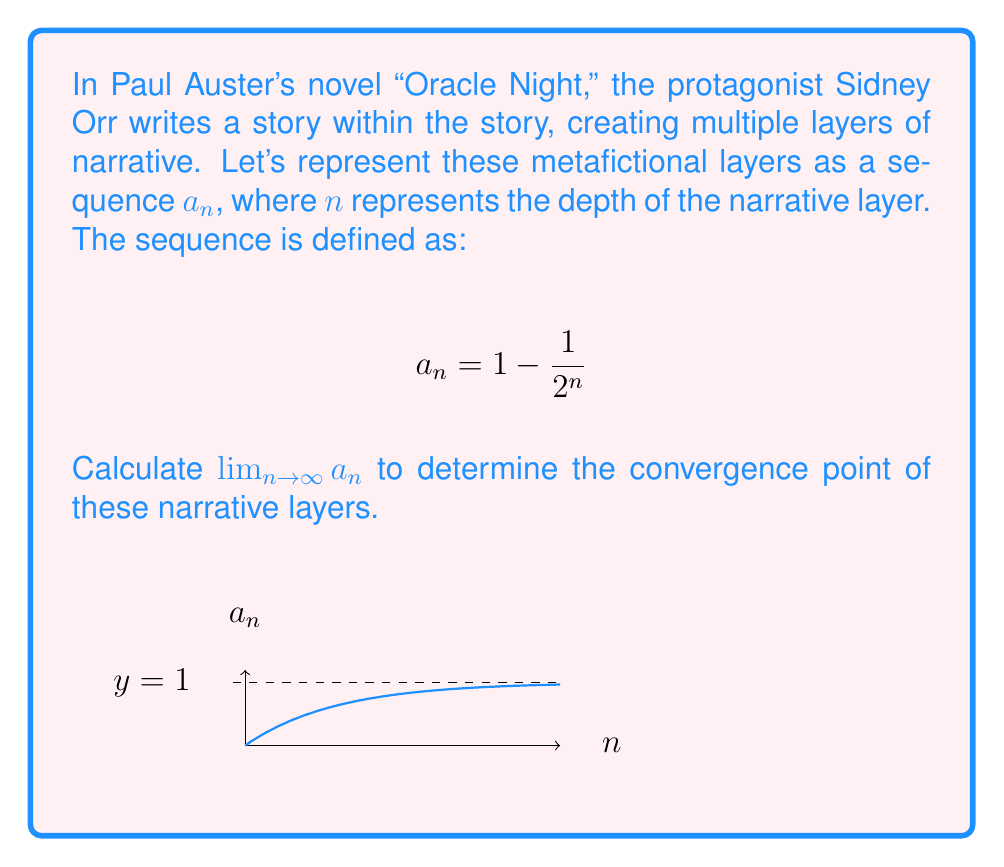Give your solution to this math problem. To calculate this limit, we'll follow these steps:

1) First, let's examine the behavior of the sequence as $n$ increases:
   For $n = 1$: $a_1 = 1 - \frac{1}{2^1} = 0.5$
   For $n = 2$: $a_2 = 1 - \frac{1}{2^2} = 0.75$
   For $n = 3$: $a_3 = 1 - \frac{1}{2^3} = 0.875$
   ...

2) We can see that as $n$ increases, $a_n$ gets closer to 1.

3) Now, let's analyze the limit:

   $$\lim_{n \to \infty} a_n = \lim_{n \to \infty} (1 - \frac{1}{2^n})$$

4) As $n$ approaches infinity, $2^n$ becomes extremely large, so $\frac{1}{2^n}$ approaches 0.

5) Therefore:
   
   $$\lim_{n \to \infty} (1 - \frac{1}{2^n}) = 1 - \lim_{n \to \infty} \frac{1}{2^n} = 1 - 0 = 1$$

6) This result can be interpreted metaphorically: as the narrative layers in "Oracle Night" become infinitely deep, they converge to a single unified story, represented by the limit of 1.
Answer: $\lim_{n \to \infty} a_n = 1$ 